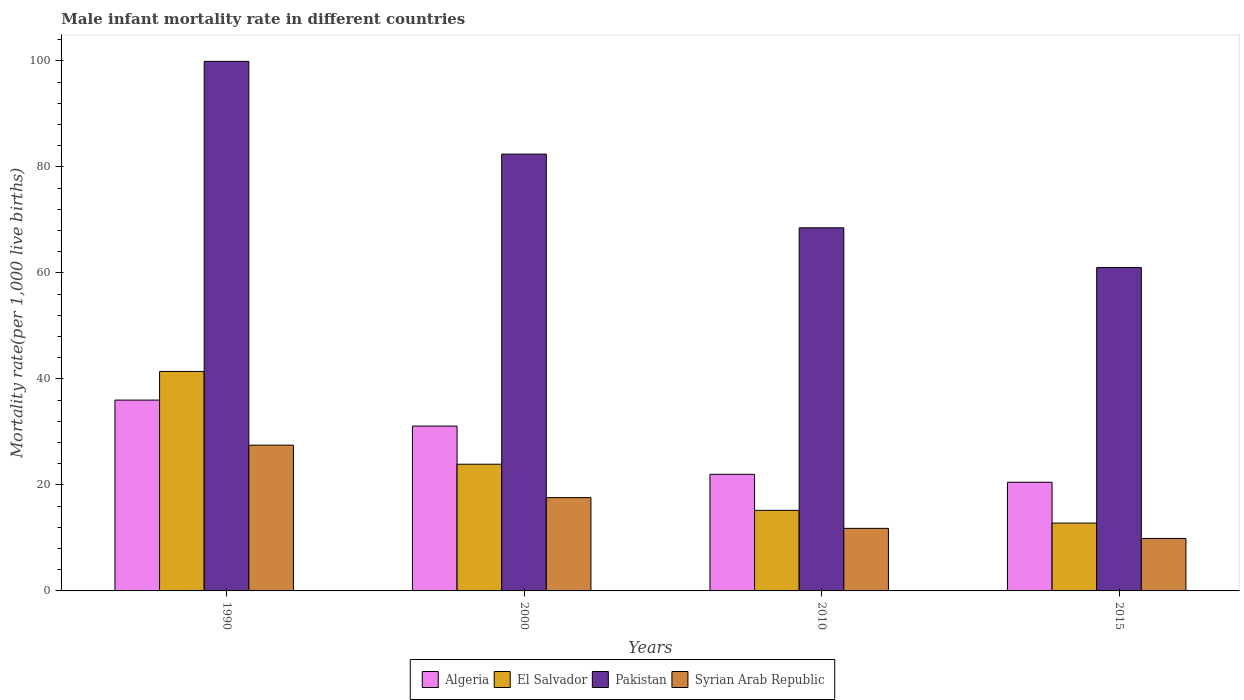How many different coloured bars are there?
Offer a very short reply. 4. How many groups of bars are there?
Keep it short and to the point. 4. Are the number of bars on each tick of the X-axis equal?
Keep it short and to the point. Yes. How many bars are there on the 4th tick from the right?
Offer a very short reply. 4. What is the male infant mortality rate in Syrian Arab Republic in 2015?
Your response must be concise. 9.9. Across all years, what is the maximum male infant mortality rate in El Salvador?
Provide a short and direct response. 41.4. Across all years, what is the minimum male infant mortality rate in Pakistan?
Keep it short and to the point. 61. In which year was the male infant mortality rate in Syrian Arab Republic minimum?
Offer a very short reply. 2015. What is the total male infant mortality rate in Algeria in the graph?
Your answer should be compact. 109.6. What is the difference between the male infant mortality rate in El Salvador in 1990 and that in 2010?
Give a very brief answer. 26.2. What is the difference between the male infant mortality rate in El Salvador in 2000 and the male infant mortality rate in Algeria in 2015?
Provide a succinct answer. 3.4. What is the average male infant mortality rate in Algeria per year?
Your answer should be very brief. 27.4. In the year 2000, what is the difference between the male infant mortality rate in Syrian Arab Republic and male infant mortality rate in El Salvador?
Make the answer very short. -6.3. In how many years, is the male infant mortality rate in El Salvador greater than 12?
Offer a terse response. 4. What is the ratio of the male infant mortality rate in Pakistan in 2000 to that in 2015?
Make the answer very short. 1.35. What is the difference between the highest and the second highest male infant mortality rate in Pakistan?
Ensure brevity in your answer.  17.5. What is the difference between the highest and the lowest male infant mortality rate in Syrian Arab Republic?
Provide a short and direct response. 17.6. Is it the case that in every year, the sum of the male infant mortality rate in Algeria and male infant mortality rate in El Salvador is greater than the sum of male infant mortality rate in Syrian Arab Republic and male infant mortality rate in Pakistan?
Offer a very short reply. No. What does the 3rd bar from the left in 2010 represents?
Provide a short and direct response. Pakistan. What does the 3rd bar from the right in 2010 represents?
Provide a short and direct response. El Salvador. Are all the bars in the graph horizontal?
Your answer should be very brief. No. How many years are there in the graph?
Offer a terse response. 4. What is the difference between two consecutive major ticks on the Y-axis?
Your response must be concise. 20. Are the values on the major ticks of Y-axis written in scientific E-notation?
Keep it short and to the point. No. Does the graph contain any zero values?
Offer a very short reply. No. Where does the legend appear in the graph?
Provide a succinct answer. Bottom center. What is the title of the graph?
Your answer should be compact. Male infant mortality rate in different countries. What is the label or title of the Y-axis?
Offer a very short reply. Mortality rate(per 1,0 live births). What is the Mortality rate(per 1,000 live births) of Algeria in 1990?
Ensure brevity in your answer.  36. What is the Mortality rate(per 1,000 live births) of El Salvador in 1990?
Provide a short and direct response. 41.4. What is the Mortality rate(per 1,000 live births) in Pakistan in 1990?
Offer a terse response. 99.9. What is the Mortality rate(per 1,000 live births) of Syrian Arab Republic in 1990?
Give a very brief answer. 27.5. What is the Mortality rate(per 1,000 live births) of Algeria in 2000?
Your response must be concise. 31.1. What is the Mortality rate(per 1,000 live births) in El Salvador in 2000?
Your answer should be compact. 23.9. What is the Mortality rate(per 1,000 live births) of Pakistan in 2000?
Your answer should be very brief. 82.4. What is the Mortality rate(per 1,000 live births) in Syrian Arab Republic in 2000?
Your answer should be compact. 17.6. What is the Mortality rate(per 1,000 live births) of Algeria in 2010?
Keep it short and to the point. 22. What is the Mortality rate(per 1,000 live births) in El Salvador in 2010?
Make the answer very short. 15.2. What is the Mortality rate(per 1,000 live births) in Pakistan in 2010?
Make the answer very short. 68.5. What is the Mortality rate(per 1,000 live births) in Syrian Arab Republic in 2010?
Your answer should be compact. 11.8. What is the Mortality rate(per 1,000 live births) of El Salvador in 2015?
Your answer should be compact. 12.8. What is the Mortality rate(per 1,000 live births) of Pakistan in 2015?
Offer a terse response. 61. What is the Mortality rate(per 1,000 live births) in Syrian Arab Republic in 2015?
Keep it short and to the point. 9.9. Across all years, what is the maximum Mortality rate(per 1,000 live births) in Algeria?
Give a very brief answer. 36. Across all years, what is the maximum Mortality rate(per 1,000 live births) of El Salvador?
Provide a short and direct response. 41.4. Across all years, what is the maximum Mortality rate(per 1,000 live births) in Pakistan?
Ensure brevity in your answer.  99.9. Across all years, what is the maximum Mortality rate(per 1,000 live births) of Syrian Arab Republic?
Your answer should be very brief. 27.5. Across all years, what is the minimum Mortality rate(per 1,000 live births) in El Salvador?
Offer a terse response. 12.8. Across all years, what is the minimum Mortality rate(per 1,000 live births) of Syrian Arab Republic?
Offer a very short reply. 9.9. What is the total Mortality rate(per 1,000 live births) in Algeria in the graph?
Provide a succinct answer. 109.6. What is the total Mortality rate(per 1,000 live births) in El Salvador in the graph?
Offer a terse response. 93.3. What is the total Mortality rate(per 1,000 live births) in Pakistan in the graph?
Make the answer very short. 311.8. What is the total Mortality rate(per 1,000 live births) of Syrian Arab Republic in the graph?
Provide a short and direct response. 66.8. What is the difference between the Mortality rate(per 1,000 live births) of El Salvador in 1990 and that in 2000?
Your response must be concise. 17.5. What is the difference between the Mortality rate(per 1,000 live births) in Pakistan in 1990 and that in 2000?
Provide a succinct answer. 17.5. What is the difference between the Mortality rate(per 1,000 live births) in Algeria in 1990 and that in 2010?
Provide a short and direct response. 14. What is the difference between the Mortality rate(per 1,000 live births) in El Salvador in 1990 and that in 2010?
Give a very brief answer. 26.2. What is the difference between the Mortality rate(per 1,000 live births) in Pakistan in 1990 and that in 2010?
Your response must be concise. 31.4. What is the difference between the Mortality rate(per 1,000 live births) in El Salvador in 1990 and that in 2015?
Your response must be concise. 28.6. What is the difference between the Mortality rate(per 1,000 live births) of Pakistan in 1990 and that in 2015?
Keep it short and to the point. 38.9. What is the difference between the Mortality rate(per 1,000 live births) in Syrian Arab Republic in 1990 and that in 2015?
Give a very brief answer. 17.6. What is the difference between the Mortality rate(per 1,000 live births) of Algeria in 2000 and that in 2010?
Your response must be concise. 9.1. What is the difference between the Mortality rate(per 1,000 live births) of Syrian Arab Republic in 2000 and that in 2010?
Offer a very short reply. 5.8. What is the difference between the Mortality rate(per 1,000 live births) in Algeria in 2000 and that in 2015?
Keep it short and to the point. 10.6. What is the difference between the Mortality rate(per 1,000 live births) of El Salvador in 2000 and that in 2015?
Your answer should be compact. 11.1. What is the difference between the Mortality rate(per 1,000 live births) in Pakistan in 2000 and that in 2015?
Make the answer very short. 21.4. What is the difference between the Mortality rate(per 1,000 live births) in Syrian Arab Republic in 2000 and that in 2015?
Keep it short and to the point. 7.7. What is the difference between the Mortality rate(per 1,000 live births) of Pakistan in 2010 and that in 2015?
Ensure brevity in your answer.  7.5. What is the difference between the Mortality rate(per 1,000 live births) in Algeria in 1990 and the Mortality rate(per 1,000 live births) in Pakistan in 2000?
Your answer should be very brief. -46.4. What is the difference between the Mortality rate(per 1,000 live births) of El Salvador in 1990 and the Mortality rate(per 1,000 live births) of Pakistan in 2000?
Keep it short and to the point. -41. What is the difference between the Mortality rate(per 1,000 live births) of El Salvador in 1990 and the Mortality rate(per 1,000 live births) of Syrian Arab Republic in 2000?
Give a very brief answer. 23.8. What is the difference between the Mortality rate(per 1,000 live births) of Pakistan in 1990 and the Mortality rate(per 1,000 live births) of Syrian Arab Republic in 2000?
Offer a terse response. 82.3. What is the difference between the Mortality rate(per 1,000 live births) in Algeria in 1990 and the Mortality rate(per 1,000 live births) in El Salvador in 2010?
Ensure brevity in your answer.  20.8. What is the difference between the Mortality rate(per 1,000 live births) in Algeria in 1990 and the Mortality rate(per 1,000 live births) in Pakistan in 2010?
Provide a short and direct response. -32.5. What is the difference between the Mortality rate(per 1,000 live births) in Algeria in 1990 and the Mortality rate(per 1,000 live births) in Syrian Arab Republic in 2010?
Your answer should be compact. 24.2. What is the difference between the Mortality rate(per 1,000 live births) in El Salvador in 1990 and the Mortality rate(per 1,000 live births) in Pakistan in 2010?
Your response must be concise. -27.1. What is the difference between the Mortality rate(per 1,000 live births) in El Salvador in 1990 and the Mortality rate(per 1,000 live births) in Syrian Arab Republic in 2010?
Offer a very short reply. 29.6. What is the difference between the Mortality rate(per 1,000 live births) of Pakistan in 1990 and the Mortality rate(per 1,000 live births) of Syrian Arab Republic in 2010?
Ensure brevity in your answer.  88.1. What is the difference between the Mortality rate(per 1,000 live births) of Algeria in 1990 and the Mortality rate(per 1,000 live births) of El Salvador in 2015?
Make the answer very short. 23.2. What is the difference between the Mortality rate(per 1,000 live births) in Algeria in 1990 and the Mortality rate(per 1,000 live births) in Pakistan in 2015?
Your answer should be compact. -25. What is the difference between the Mortality rate(per 1,000 live births) in Algeria in 1990 and the Mortality rate(per 1,000 live births) in Syrian Arab Republic in 2015?
Your response must be concise. 26.1. What is the difference between the Mortality rate(per 1,000 live births) of El Salvador in 1990 and the Mortality rate(per 1,000 live births) of Pakistan in 2015?
Your response must be concise. -19.6. What is the difference between the Mortality rate(per 1,000 live births) of El Salvador in 1990 and the Mortality rate(per 1,000 live births) of Syrian Arab Republic in 2015?
Give a very brief answer. 31.5. What is the difference between the Mortality rate(per 1,000 live births) in Algeria in 2000 and the Mortality rate(per 1,000 live births) in Pakistan in 2010?
Offer a very short reply. -37.4. What is the difference between the Mortality rate(per 1,000 live births) of Algeria in 2000 and the Mortality rate(per 1,000 live births) of Syrian Arab Republic in 2010?
Offer a very short reply. 19.3. What is the difference between the Mortality rate(per 1,000 live births) in El Salvador in 2000 and the Mortality rate(per 1,000 live births) in Pakistan in 2010?
Make the answer very short. -44.6. What is the difference between the Mortality rate(per 1,000 live births) in Pakistan in 2000 and the Mortality rate(per 1,000 live births) in Syrian Arab Republic in 2010?
Your answer should be compact. 70.6. What is the difference between the Mortality rate(per 1,000 live births) in Algeria in 2000 and the Mortality rate(per 1,000 live births) in Pakistan in 2015?
Give a very brief answer. -29.9. What is the difference between the Mortality rate(per 1,000 live births) of Algeria in 2000 and the Mortality rate(per 1,000 live births) of Syrian Arab Republic in 2015?
Offer a very short reply. 21.2. What is the difference between the Mortality rate(per 1,000 live births) in El Salvador in 2000 and the Mortality rate(per 1,000 live births) in Pakistan in 2015?
Keep it short and to the point. -37.1. What is the difference between the Mortality rate(per 1,000 live births) of El Salvador in 2000 and the Mortality rate(per 1,000 live births) of Syrian Arab Republic in 2015?
Make the answer very short. 14. What is the difference between the Mortality rate(per 1,000 live births) of Pakistan in 2000 and the Mortality rate(per 1,000 live births) of Syrian Arab Republic in 2015?
Your response must be concise. 72.5. What is the difference between the Mortality rate(per 1,000 live births) in Algeria in 2010 and the Mortality rate(per 1,000 live births) in Pakistan in 2015?
Provide a succinct answer. -39. What is the difference between the Mortality rate(per 1,000 live births) of El Salvador in 2010 and the Mortality rate(per 1,000 live births) of Pakistan in 2015?
Provide a short and direct response. -45.8. What is the difference between the Mortality rate(per 1,000 live births) of El Salvador in 2010 and the Mortality rate(per 1,000 live births) of Syrian Arab Republic in 2015?
Your response must be concise. 5.3. What is the difference between the Mortality rate(per 1,000 live births) in Pakistan in 2010 and the Mortality rate(per 1,000 live births) in Syrian Arab Republic in 2015?
Provide a succinct answer. 58.6. What is the average Mortality rate(per 1,000 live births) of Algeria per year?
Provide a short and direct response. 27.4. What is the average Mortality rate(per 1,000 live births) in El Salvador per year?
Your response must be concise. 23.32. What is the average Mortality rate(per 1,000 live births) of Pakistan per year?
Your answer should be very brief. 77.95. What is the average Mortality rate(per 1,000 live births) of Syrian Arab Republic per year?
Offer a terse response. 16.7. In the year 1990, what is the difference between the Mortality rate(per 1,000 live births) of Algeria and Mortality rate(per 1,000 live births) of Pakistan?
Your response must be concise. -63.9. In the year 1990, what is the difference between the Mortality rate(per 1,000 live births) in El Salvador and Mortality rate(per 1,000 live births) in Pakistan?
Provide a succinct answer. -58.5. In the year 1990, what is the difference between the Mortality rate(per 1,000 live births) in El Salvador and Mortality rate(per 1,000 live births) in Syrian Arab Republic?
Give a very brief answer. 13.9. In the year 1990, what is the difference between the Mortality rate(per 1,000 live births) in Pakistan and Mortality rate(per 1,000 live births) in Syrian Arab Republic?
Provide a succinct answer. 72.4. In the year 2000, what is the difference between the Mortality rate(per 1,000 live births) in Algeria and Mortality rate(per 1,000 live births) in El Salvador?
Give a very brief answer. 7.2. In the year 2000, what is the difference between the Mortality rate(per 1,000 live births) in Algeria and Mortality rate(per 1,000 live births) in Pakistan?
Your answer should be compact. -51.3. In the year 2000, what is the difference between the Mortality rate(per 1,000 live births) of El Salvador and Mortality rate(per 1,000 live births) of Pakistan?
Your answer should be compact. -58.5. In the year 2000, what is the difference between the Mortality rate(per 1,000 live births) of El Salvador and Mortality rate(per 1,000 live births) of Syrian Arab Republic?
Offer a terse response. 6.3. In the year 2000, what is the difference between the Mortality rate(per 1,000 live births) of Pakistan and Mortality rate(per 1,000 live births) of Syrian Arab Republic?
Your answer should be compact. 64.8. In the year 2010, what is the difference between the Mortality rate(per 1,000 live births) of Algeria and Mortality rate(per 1,000 live births) of El Salvador?
Provide a succinct answer. 6.8. In the year 2010, what is the difference between the Mortality rate(per 1,000 live births) in Algeria and Mortality rate(per 1,000 live births) in Pakistan?
Ensure brevity in your answer.  -46.5. In the year 2010, what is the difference between the Mortality rate(per 1,000 live births) of El Salvador and Mortality rate(per 1,000 live births) of Pakistan?
Make the answer very short. -53.3. In the year 2010, what is the difference between the Mortality rate(per 1,000 live births) in El Salvador and Mortality rate(per 1,000 live births) in Syrian Arab Republic?
Your answer should be compact. 3.4. In the year 2010, what is the difference between the Mortality rate(per 1,000 live births) in Pakistan and Mortality rate(per 1,000 live births) in Syrian Arab Republic?
Give a very brief answer. 56.7. In the year 2015, what is the difference between the Mortality rate(per 1,000 live births) of Algeria and Mortality rate(per 1,000 live births) of Pakistan?
Your response must be concise. -40.5. In the year 2015, what is the difference between the Mortality rate(per 1,000 live births) of El Salvador and Mortality rate(per 1,000 live births) of Pakistan?
Your response must be concise. -48.2. In the year 2015, what is the difference between the Mortality rate(per 1,000 live births) in Pakistan and Mortality rate(per 1,000 live births) in Syrian Arab Republic?
Offer a very short reply. 51.1. What is the ratio of the Mortality rate(per 1,000 live births) of Algeria in 1990 to that in 2000?
Offer a very short reply. 1.16. What is the ratio of the Mortality rate(per 1,000 live births) in El Salvador in 1990 to that in 2000?
Make the answer very short. 1.73. What is the ratio of the Mortality rate(per 1,000 live births) in Pakistan in 1990 to that in 2000?
Provide a short and direct response. 1.21. What is the ratio of the Mortality rate(per 1,000 live births) of Syrian Arab Republic in 1990 to that in 2000?
Ensure brevity in your answer.  1.56. What is the ratio of the Mortality rate(per 1,000 live births) of Algeria in 1990 to that in 2010?
Your response must be concise. 1.64. What is the ratio of the Mortality rate(per 1,000 live births) of El Salvador in 1990 to that in 2010?
Ensure brevity in your answer.  2.72. What is the ratio of the Mortality rate(per 1,000 live births) in Pakistan in 1990 to that in 2010?
Keep it short and to the point. 1.46. What is the ratio of the Mortality rate(per 1,000 live births) of Syrian Arab Republic in 1990 to that in 2010?
Make the answer very short. 2.33. What is the ratio of the Mortality rate(per 1,000 live births) in Algeria in 1990 to that in 2015?
Give a very brief answer. 1.76. What is the ratio of the Mortality rate(per 1,000 live births) of El Salvador in 1990 to that in 2015?
Provide a succinct answer. 3.23. What is the ratio of the Mortality rate(per 1,000 live births) in Pakistan in 1990 to that in 2015?
Provide a succinct answer. 1.64. What is the ratio of the Mortality rate(per 1,000 live births) in Syrian Arab Republic in 1990 to that in 2015?
Keep it short and to the point. 2.78. What is the ratio of the Mortality rate(per 1,000 live births) of Algeria in 2000 to that in 2010?
Ensure brevity in your answer.  1.41. What is the ratio of the Mortality rate(per 1,000 live births) of El Salvador in 2000 to that in 2010?
Your response must be concise. 1.57. What is the ratio of the Mortality rate(per 1,000 live births) of Pakistan in 2000 to that in 2010?
Your response must be concise. 1.2. What is the ratio of the Mortality rate(per 1,000 live births) of Syrian Arab Republic in 2000 to that in 2010?
Keep it short and to the point. 1.49. What is the ratio of the Mortality rate(per 1,000 live births) of Algeria in 2000 to that in 2015?
Your response must be concise. 1.52. What is the ratio of the Mortality rate(per 1,000 live births) in El Salvador in 2000 to that in 2015?
Provide a short and direct response. 1.87. What is the ratio of the Mortality rate(per 1,000 live births) in Pakistan in 2000 to that in 2015?
Offer a terse response. 1.35. What is the ratio of the Mortality rate(per 1,000 live births) in Syrian Arab Republic in 2000 to that in 2015?
Offer a very short reply. 1.78. What is the ratio of the Mortality rate(per 1,000 live births) in Algeria in 2010 to that in 2015?
Give a very brief answer. 1.07. What is the ratio of the Mortality rate(per 1,000 live births) of El Salvador in 2010 to that in 2015?
Provide a short and direct response. 1.19. What is the ratio of the Mortality rate(per 1,000 live births) in Pakistan in 2010 to that in 2015?
Ensure brevity in your answer.  1.12. What is the ratio of the Mortality rate(per 1,000 live births) in Syrian Arab Republic in 2010 to that in 2015?
Offer a very short reply. 1.19. What is the difference between the highest and the second highest Mortality rate(per 1,000 live births) of Algeria?
Give a very brief answer. 4.9. What is the difference between the highest and the lowest Mortality rate(per 1,000 live births) in Algeria?
Ensure brevity in your answer.  15.5. What is the difference between the highest and the lowest Mortality rate(per 1,000 live births) in El Salvador?
Keep it short and to the point. 28.6. What is the difference between the highest and the lowest Mortality rate(per 1,000 live births) in Pakistan?
Your answer should be very brief. 38.9. What is the difference between the highest and the lowest Mortality rate(per 1,000 live births) in Syrian Arab Republic?
Offer a terse response. 17.6. 